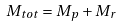Convert formula to latex. <formula><loc_0><loc_0><loc_500><loc_500>M _ { t o t } = M _ { p } + M _ { r }</formula> 